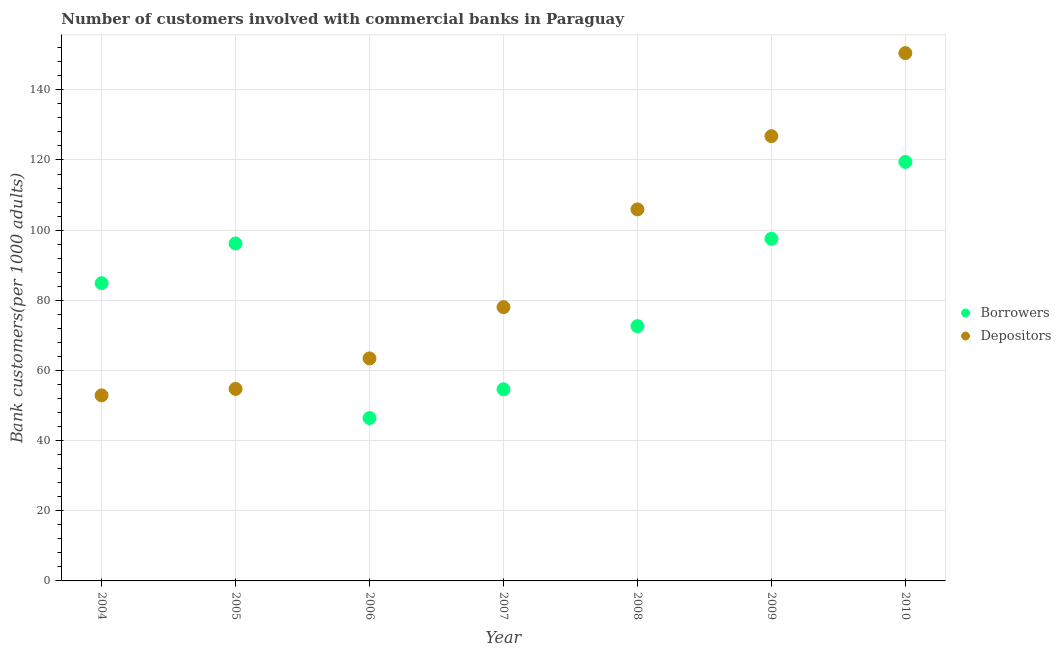Is the number of dotlines equal to the number of legend labels?
Give a very brief answer. Yes. What is the number of depositors in 2007?
Make the answer very short. 78.05. Across all years, what is the maximum number of borrowers?
Give a very brief answer. 119.45. Across all years, what is the minimum number of borrowers?
Offer a very short reply. 46.43. What is the total number of borrowers in the graph?
Ensure brevity in your answer.  571.75. What is the difference between the number of borrowers in 2007 and that in 2009?
Offer a very short reply. -42.91. What is the difference between the number of borrowers in 2007 and the number of depositors in 2008?
Provide a succinct answer. -51.29. What is the average number of depositors per year?
Offer a very short reply. 90.33. In the year 2010, what is the difference between the number of borrowers and number of depositors?
Your response must be concise. -31.02. What is the ratio of the number of depositors in 2004 to that in 2010?
Your answer should be very brief. 0.35. Is the difference between the number of borrowers in 2007 and 2008 greater than the difference between the number of depositors in 2007 and 2008?
Your response must be concise. Yes. What is the difference between the highest and the second highest number of depositors?
Provide a succinct answer. 23.67. What is the difference between the highest and the lowest number of borrowers?
Ensure brevity in your answer.  73.02. Does the number of depositors monotonically increase over the years?
Your answer should be compact. Yes. How many dotlines are there?
Offer a very short reply. 2. How many years are there in the graph?
Provide a short and direct response. 7. What is the difference between two consecutive major ticks on the Y-axis?
Offer a terse response. 20. Are the values on the major ticks of Y-axis written in scientific E-notation?
Your answer should be very brief. No. Does the graph contain grids?
Offer a very short reply. Yes. How many legend labels are there?
Make the answer very short. 2. What is the title of the graph?
Give a very brief answer. Number of customers involved with commercial banks in Paraguay. What is the label or title of the Y-axis?
Provide a short and direct response. Bank customers(per 1000 adults). What is the Bank customers(per 1000 adults) in Borrowers in 2004?
Offer a very short reply. 84.87. What is the Bank customers(per 1000 adults) in Depositors in 2004?
Make the answer very short. 52.9. What is the Bank customers(per 1000 adults) in Borrowers in 2005?
Ensure brevity in your answer.  96.2. What is the Bank customers(per 1000 adults) of Depositors in 2005?
Give a very brief answer. 54.74. What is the Bank customers(per 1000 adults) of Borrowers in 2006?
Provide a short and direct response. 46.43. What is the Bank customers(per 1000 adults) of Depositors in 2006?
Offer a terse response. 63.43. What is the Bank customers(per 1000 adults) of Borrowers in 2007?
Your response must be concise. 54.63. What is the Bank customers(per 1000 adults) in Depositors in 2007?
Your answer should be compact. 78.05. What is the Bank customers(per 1000 adults) in Borrowers in 2008?
Give a very brief answer. 72.63. What is the Bank customers(per 1000 adults) of Depositors in 2008?
Offer a very short reply. 105.92. What is the Bank customers(per 1000 adults) of Borrowers in 2009?
Offer a terse response. 97.54. What is the Bank customers(per 1000 adults) in Depositors in 2009?
Keep it short and to the point. 126.8. What is the Bank customers(per 1000 adults) of Borrowers in 2010?
Provide a short and direct response. 119.45. What is the Bank customers(per 1000 adults) of Depositors in 2010?
Keep it short and to the point. 150.47. Across all years, what is the maximum Bank customers(per 1000 adults) in Borrowers?
Your response must be concise. 119.45. Across all years, what is the maximum Bank customers(per 1000 adults) of Depositors?
Keep it short and to the point. 150.47. Across all years, what is the minimum Bank customers(per 1000 adults) in Borrowers?
Provide a succinct answer. 46.43. Across all years, what is the minimum Bank customers(per 1000 adults) in Depositors?
Your response must be concise. 52.9. What is the total Bank customers(per 1000 adults) of Borrowers in the graph?
Keep it short and to the point. 571.75. What is the total Bank customers(per 1000 adults) in Depositors in the graph?
Ensure brevity in your answer.  632.31. What is the difference between the Bank customers(per 1000 adults) in Borrowers in 2004 and that in 2005?
Your response must be concise. -11.33. What is the difference between the Bank customers(per 1000 adults) of Depositors in 2004 and that in 2005?
Give a very brief answer. -1.85. What is the difference between the Bank customers(per 1000 adults) of Borrowers in 2004 and that in 2006?
Your response must be concise. 38.44. What is the difference between the Bank customers(per 1000 adults) of Depositors in 2004 and that in 2006?
Give a very brief answer. -10.54. What is the difference between the Bank customers(per 1000 adults) of Borrowers in 2004 and that in 2007?
Give a very brief answer. 30.24. What is the difference between the Bank customers(per 1000 adults) in Depositors in 2004 and that in 2007?
Give a very brief answer. -25.15. What is the difference between the Bank customers(per 1000 adults) in Borrowers in 2004 and that in 2008?
Provide a short and direct response. 12.24. What is the difference between the Bank customers(per 1000 adults) of Depositors in 2004 and that in 2008?
Your response must be concise. -53.02. What is the difference between the Bank customers(per 1000 adults) in Borrowers in 2004 and that in 2009?
Your response must be concise. -12.66. What is the difference between the Bank customers(per 1000 adults) in Depositors in 2004 and that in 2009?
Provide a short and direct response. -73.9. What is the difference between the Bank customers(per 1000 adults) of Borrowers in 2004 and that in 2010?
Make the answer very short. -34.57. What is the difference between the Bank customers(per 1000 adults) of Depositors in 2004 and that in 2010?
Ensure brevity in your answer.  -97.57. What is the difference between the Bank customers(per 1000 adults) in Borrowers in 2005 and that in 2006?
Your answer should be very brief. 49.77. What is the difference between the Bank customers(per 1000 adults) of Depositors in 2005 and that in 2006?
Ensure brevity in your answer.  -8.69. What is the difference between the Bank customers(per 1000 adults) in Borrowers in 2005 and that in 2007?
Your answer should be very brief. 41.57. What is the difference between the Bank customers(per 1000 adults) in Depositors in 2005 and that in 2007?
Ensure brevity in your answer.  -23.31. What is the difference between the Bank customers(per 1000 adults) in Borrowers in 2005 and that in 2008?
Provide a succinct answer. 23.57. What is the difference between the Bank customers(per 1000 adults) in Depositors in 2005 and that in 2008?
Keep it short and to the point. -51.17. What is the difference between the Bank customers(per 1000 adults) in Borrowers in 2005 and that in 2009?
Give a very brief answer. -1.33. What is the difference between the Bank customers(per 1000 adults) in Depositors in 2005 and that in 2009?
Your response must be concise. -72.05. What is the difference between the Bank customers(per 1000 adults) in Borrowers in 2005 and that in 2010?
Provide a succinct answer. -23.24. What is the difference between the Bank customers(per 1000 adults) of Depositors in 2005 and that in 2010?
Your answer should be very brief. -95.72. What is the difference between the Bank customers(per 1000 adults) of Borrowers in 2006 and that in 2007?
Make the answer very short. -8.2. What is the difference between the Bank customers(per 1000 adults) in Depositors in 2006 and that in 2007?
Your response must be concise. -14.62. What is the difference between the Bank customers(per 1000 adults) in Borrowers in 2006 and that in 2008?
Your response must be concise. -26.2. What is the difference between the Bank customers(per 1000 adults) in Depositors in 2006 and that in 2008?
Keep it short and to the point. -42.48. What is the difference between the Bank customers(per 1000 adults) in Borrowers in 2006 and that in 2009?
Your answer should be compact. -51.11. What is the difference between the Bank customers(per 1000 adults) of Depositors in 2006 and that in 2009?
Provide a succinct answer. -63.36. What is the difference between the Bank customers(per 1000 adults) of Borrowers in 2006 and that in 2010?
Your response must be concise. -73.02. What is the difference between the Bank customers(per 1000 adults) of Depositors in 2006 and that in 2010?
Offer a terse response. -87.03. What is the difference between the Bank customers(per 1000 adults) of Borrowers in 2007 and that in 2008?
Your answer should be very brief. -18. What is the difference between the Bank customers(per 1000 adults) of Depositors in 2007 and that in 2008?
Make the answer very short. -27.87. What is the difference between the Bank customers(per 1000 adults) in Borrowers in 2007 and that in 2009?
Keep it short and to the point. -42.91. What is the difference between the Bank customers(per 1000 adults) in Depositors in 2007 and that in 2009?
Provide a succinct answer. -48.75. What is the difference between the Bank customers(per 1000 adults) in Borrowers in 2007 and that in 2010?
Offer a terse response. -64.81. What is the difference between the Bank customers(per 1000 adults) of Depositors in 2007 and that in 2010?
Keep it short and to the point. -72.42. What is the difference between the Bank customers(per 1000 adults) in Borrowers in 2008 and that in 2009?
Make the answer very short. -24.9. What is the difference between the Bank customers(per 1000 adults) of Depositors in 2008 and that in 2009?
Make the answer very short. -20.88. What is the difference between the Bank customers(per 1000 adults) of Borrowers in 2008 and that in 2010?
Your response must be concise. -46.81. What is the difference between the Bank customers(per 1000 adults) in Depositors in 2008 and that in 2010?
Make the answer very short. -44.55. What is the difference between the Bank customers(per 1000 adults) of Borrowers in 2009 and that in 2010?
Make the answer very short. -21.91. What is the difference between the Bank customers(per 1000 adults) of Depositors in 2009 and that in 2010?
Keep it short and to the point. -23.67. What is the difference between the Bank customers(per 1000 adults) of Borrowers in 2004 and the Bank customers(per 1000 adults) of Depositors in 2005?
Make the answer very short. 30.13. What is the difference between the Bank customers(per 1000 adults) in Borrowers in 2004 and the Bank customers(per 1000 adults) in Depositors in 2006?
Ensure brevity in your answer.  21.44. What is the difference between the Bank customers(per 1000 adults) of Borrowers in 2004 and the Bank customers(per 1000 adults) of Depositors in 2007?
Make the answer very short. 6.82. What is the difference between the Bank customers(per 1000 adults) of Borrowers in 2004 and the Bank customers(per 1000 adults) of Depositors in 2008?
Give a very brief answer. -21.04. What is the difference between the Bank customers(per 1000 adults) in Borrowers in 2004 and the Bank customers(per 1000 adults) in Depositors in 2009?
Offer a terse response. -41.92. What is the difference between the Bank customers(per 1000 adults) of Borrowers in 2004 and the Bank customers(per 1000 adults) of Depositors in 2010?
Provide a succinct answer. -65.59. What is the difference between the Bank customers(per 1000 adults) of Borrowers in 2005 and the Bank customers(per 1000 adults) of Depositors in 2006?
Give a very brief answer. 32.77. What is the difference between the Bank customers(per 1000 adults) in Borrowers in 2005 and the Bank customers(per 1000 adults) in Depositors in 2007?
Your answer should be very brief. 18.15. What is the difference between the Bank customers(per 1000 adults) of Borrowers in 2005 and the Bank customers(per 1000 adults) of Depositors in 2008?
Provide a succinct answer. -9.71. What is the difference between the Bank customers(per 1000 adults) in Borrowers in 2005 and the Bank customers(per 1000 adults) in Depositors in 2009?
Your answer should be compact. -30.59. What is the difference between the Bank customers(per 1000 adults) of Borrowers in 2005 and the Bank customers(per 1000 adults) of Depositors in 2010?
Your response must be concise. -54.26. What is the difference between the Bank customers(per 1000 adults) in Borrowers in 2006 and the Bank customers(per 1000 adults) in Depositors in 2007?
Your response must be concise. -31.62. What is the difference between the Bank customers(per 1000 adults) of Borrowers in 2006 and the Bank customers(per 1000 adults) of Depositors in 2008?
Ensure brevity in your answer.  -59.49. What is the difference between the Bank customers(per 1000 adults) of Borrowers in 2006 and the Bank customers(per 1000 adults) of Depositors in 2009?
Offer a terse response. -80.37. What is the difference between the Bank customers(per 1000 adults) in Borrowers in 2006 and the Bank customers(per 1000 adults) in Depositors in 2010?
Keep it short and to the point. -104.04. What is the difference between the Bank customers(per 1000 adults) of Borrowers in 2007 and the Bank customers(per 1000 adults) of Depositors in 2008?
Your answer should be compact. -51.29. What is the difference between the Bank customers(per 1000 adults) in Borrowers in 2007 and the Bank customers(per 1000 adults) in Depositors in 2009?
Ensure brevity in your answer.  -72.17. What is the difference between the Bank customers(per 1000 adults) in Borrowers in 2007 and the Bank customers(per 1000 adults) in Depositors in 2010?
Provide a succinct answer. -95.84. What is the difference between the Bank customers(per 1000 adults) of Borrowers in 2008 and the Bank customers(per 1000 adults) of Depositors in 2009?
Provide a succinct answer. -54.16. What is the difference between the Bank customers(per 1000 adults) in Borrowers in 2008 and the Bank customers(per 1000 adults) in Depositors in 2010?
Ensure brevity in your answer.  -77.83. What is the difference between the Bank customers(per 1000 adults) in Borrowers in 2009 and the Bank customers(per 1000 adults) in Depositors in 2010?
Keep it short and to the point. -52.93. What is the average Bank customers(per 1000 adults) in Borrowers per year?
Your answer should be very brief. 81.68. What is the average Bank customers(per 1000 adults) of Depositors per year?
Offer a terse response. 90.33. In the year 2004, what is the difference between the Bank customers(per 1000 adults) in Borrowers and Bank customers(per 1000 adults) in Depositors?
Provide a short and direct response. 31.98. In the year 2005, what is the difference between the Bank customers(per 1000 adults) in Borrowers and Bank customers(per 1000 adults) in Depositors?
Provide a short and direct response. 41.46. In the year 2006, what is the difference between the Bank customers(per 1000 adults) in Borrowers and Bank customers(per 1000 adults) in Depositors?
Provide a short and direct response. -17. In the year 2007, what is the difference between the Bank customers(per 1000 adults) of Borrowers and Bank customers(per 1000 adults) of Depositors?
Keep it short and to the point. -23.42. In the year 2008, what is the difference between the Bank customers(per 1000 adults) in Borrowers and Bank customers(per 1000 adults) in Depositors?
Provide a succinct answer. -33.28. In the year 2009, what is the difference between the Bank customers(per 1000 adults) in Borrowers and Bank customers(per 1000 adults) in Depositors?
Provide a short and direct response. -29.26. In the year 2010, what is the difference between the Bank customers(per 1000 adults) in Borrowers and Bank customers(per 1000 adults) in Depositors?
Your answer should be compact. -31.02. What is the ratio of the Bank customers(per 1000 adults) of Borrowers in 2004 to that in 2005?
Offer a very short reply. 0.88. What is the ratio of the Bank customers(per 1000 adults) of Depositors in 2004 to that in 2005?
Offer a terse response. 0.97. What is the ratio of the Bank customers(per 1000 adults) of Borrowers in 2004 to that in 2006?
Make the answer very short. 1.83. What is the ratio of the Bank customers(per 1000 adults) of Depositors in 2004 to that in 2006?
Make the answer very short. 0.83. What is the ratio of the Bank customers(per 1000 adults) in Borrowers in 2004 to that in 2007?
Offer a terse response. 1.55. What is the ratio of the Bank customers(per 1000 adults) of Depositors in 2004 to that in 2007?
Ensure brevity in your answer.  0.68. What is the ratio of the Bank customers(per 1000 adults) in Borrowers in 2004 to that in 2008?
Your answer should be compact. 1.17. What is the ratio of the Bank customers(per 1000 adults) in Depositors in 2004 to that in 2008?
Offer a very short reply. 0.5. What is the ratio of the Bank customers(per 1000 adults) of Borrowers in 2004 to that in 2009?
Keep it short and to the point. 0.87. What is the ratio of the Bank customers(per 1000 adults) in Depositors in 2004 to that in 2009?
Offer a terse response. 0.42. What is the ratio of the Bank customers(per 1000 adults) of Borrowers in 2004 to that in 2010?
Make the answer very short. 0.71. What is the ratio of the Bank customers(per 1000 adults) in Depositors in 2004 to that in 2010?
Provide a succinct answer. 0.35. What is the ratio of the Bank customers(per 1000 adults) of Borrowers in 2005 to that in 2006?
Your response must be concise. 2.07. What is the ratio of the Bank customers(per 1000 adults) in Depositors in 2005 to that in 2006?
Your answer should be very brief. 0.86. What is the ratio of the Bank customers(per 1000 adults) in Borrowers in 2005 to that in 2007?
Give a very brief answer. 1.76. What is the ratio of the Bank customers(per 1000 adults) in Depositors in 2005 to that in 2007?
Provide a succinct answer. 0.7. What is the ratio of the Bank customers(per 1000 adults) in Borrowers in 2005 to that in 2008?
Your answer should be very brief. 1.32. What is the ratio of the Bank customers(per 1000 adults) of Depositors in 2005 to that in 2008?
Make the answer very short. 0.52. What is the ratio of the Bank customers(per 1000 adults) in Borrowers in 2005 to that in 2009?
Your answer should be very brief. 0.99. What is the ratio of the Bank customers(per 1000 adults) in Depositors in 2005 to that in 2009?
Offer a terse response. 0.43. What is the ratio of the Bank customers(per 1000 adults) in Borrowers in 2005 to that in 2010?
Make the answer very short. 0.81. What is the ratio of the Bank customers(per 1000 adults) in Depositors in 2005 to that in 2010?
Make the answer very short. 0.36. What is the ratio of the Bank customers(per 1000 adults) of Borrowers in 2006 to that in 2007?
Provide a succinct answer. 0.85. What is the ratio of the Bank customers(per 1000 adults) of Depositors in 2006 to that in 2007?
Give a very brief answer. 0.81. What is the ratio of the Bank customers(per 1000 adults) in Borrowers in 2006 to that in 2008?
Provide a short and direct response. 0.64. What is the ratio of the Bank customers(per 1000 adults) of Depositors in 2006 to that in 2008?
Provide a short and direct response. 0.6. What is the ratio of the Bank customers(per 1000 adults) in Borrowers in 2006 to that in 2009?
Keep it short and to the point. 0.48. What is the ratio of the Bank customers(per 1000 adults) in Depositors in 2006 to that in 2009?
Offer a very short reply. 0.5. What is the ratio of the Bank customers(per 1000 adults) of Borrowers in 2006 to that in 2010?
Offer a terse response. 0.39. What is the ratio of the Bank customers(per 1000 adults) of Depositors in 2006 to that in 2010?
Give a very brief answer. 0.42. What is the ratio of the Bank customers(per 1000 adults) in Borrowers in 2007 to that in 2008?
Your answer should be very brief. 0.75. What is the ratio of the Bank customers(per 1000 adults) in Depositors in 2007 to that in 2008?
Make the answer very short. 0.74. What is the ratio of the Bank customers(per 1000 adults) in Borrowers in 2007 to that in 2009?
Ensure brevity in your answer.  0.56. What is the ratio of the Bank customers(per 1000 adults) in Depositors in 2007 to that in 2009?
Provide a short and direct response. 0.62. What is the ratio of the Bank customers(per 1000 adults) of Borrowers in 2007 to that in 2010?
Provide a short and direct response. 0.46. What is the ratio of the Bank customers(per 1000 adults) in Depositors in 2007 to that in 2010?
Offer a very short reply. 0.52. What is the ratio of the Bank customers(per 1000 adults) of Borrowers in 2008 to that in 2009?
Your answer should be very brief. 0.74. What is the ratio of the Bank customers(per 1000 adults) in Depositors in 2008 to that in 2009?
Your answer should be very brief. 0.84. What is the ratio of the Bank customers(per 1000 adults) in Borrowers in 2008 to that in 2010?
Make the answer very short. 0.61. What is the ratio of the Bank customers(per 1000 adults) in Depositors in 2008 to that in 2010?
Offer a very short reply. 0.7. What is the ratio of the Bank customers(per 1000 adults) in Borrowers in 2009 to that in 2010?
Keep it short and to the point. 0.82. What is the ratio of the Bank customers(per 1000 adults) in Depositors in 2009 to that in 2010?
Make the answer very short. 0.84. What is the difference between the highest and the second highest Bank customers(per 1000 adults) of Borrowers?
Offer a very short reply. 21.91. What is the difference between the highest and the second highest Bank customers(per 1000 adults) of Depositors?
Your answer should be very brief. 23.67. What is the difference between the highest and the lowest Bank customers(per 1000 adults) of Borrowers?
Make the answer very short. 73.02. What is the difference between the highest and the lowest Bank customers(per 1000 adults) in Depositors?
Keep it short and to the point. 97.57. 